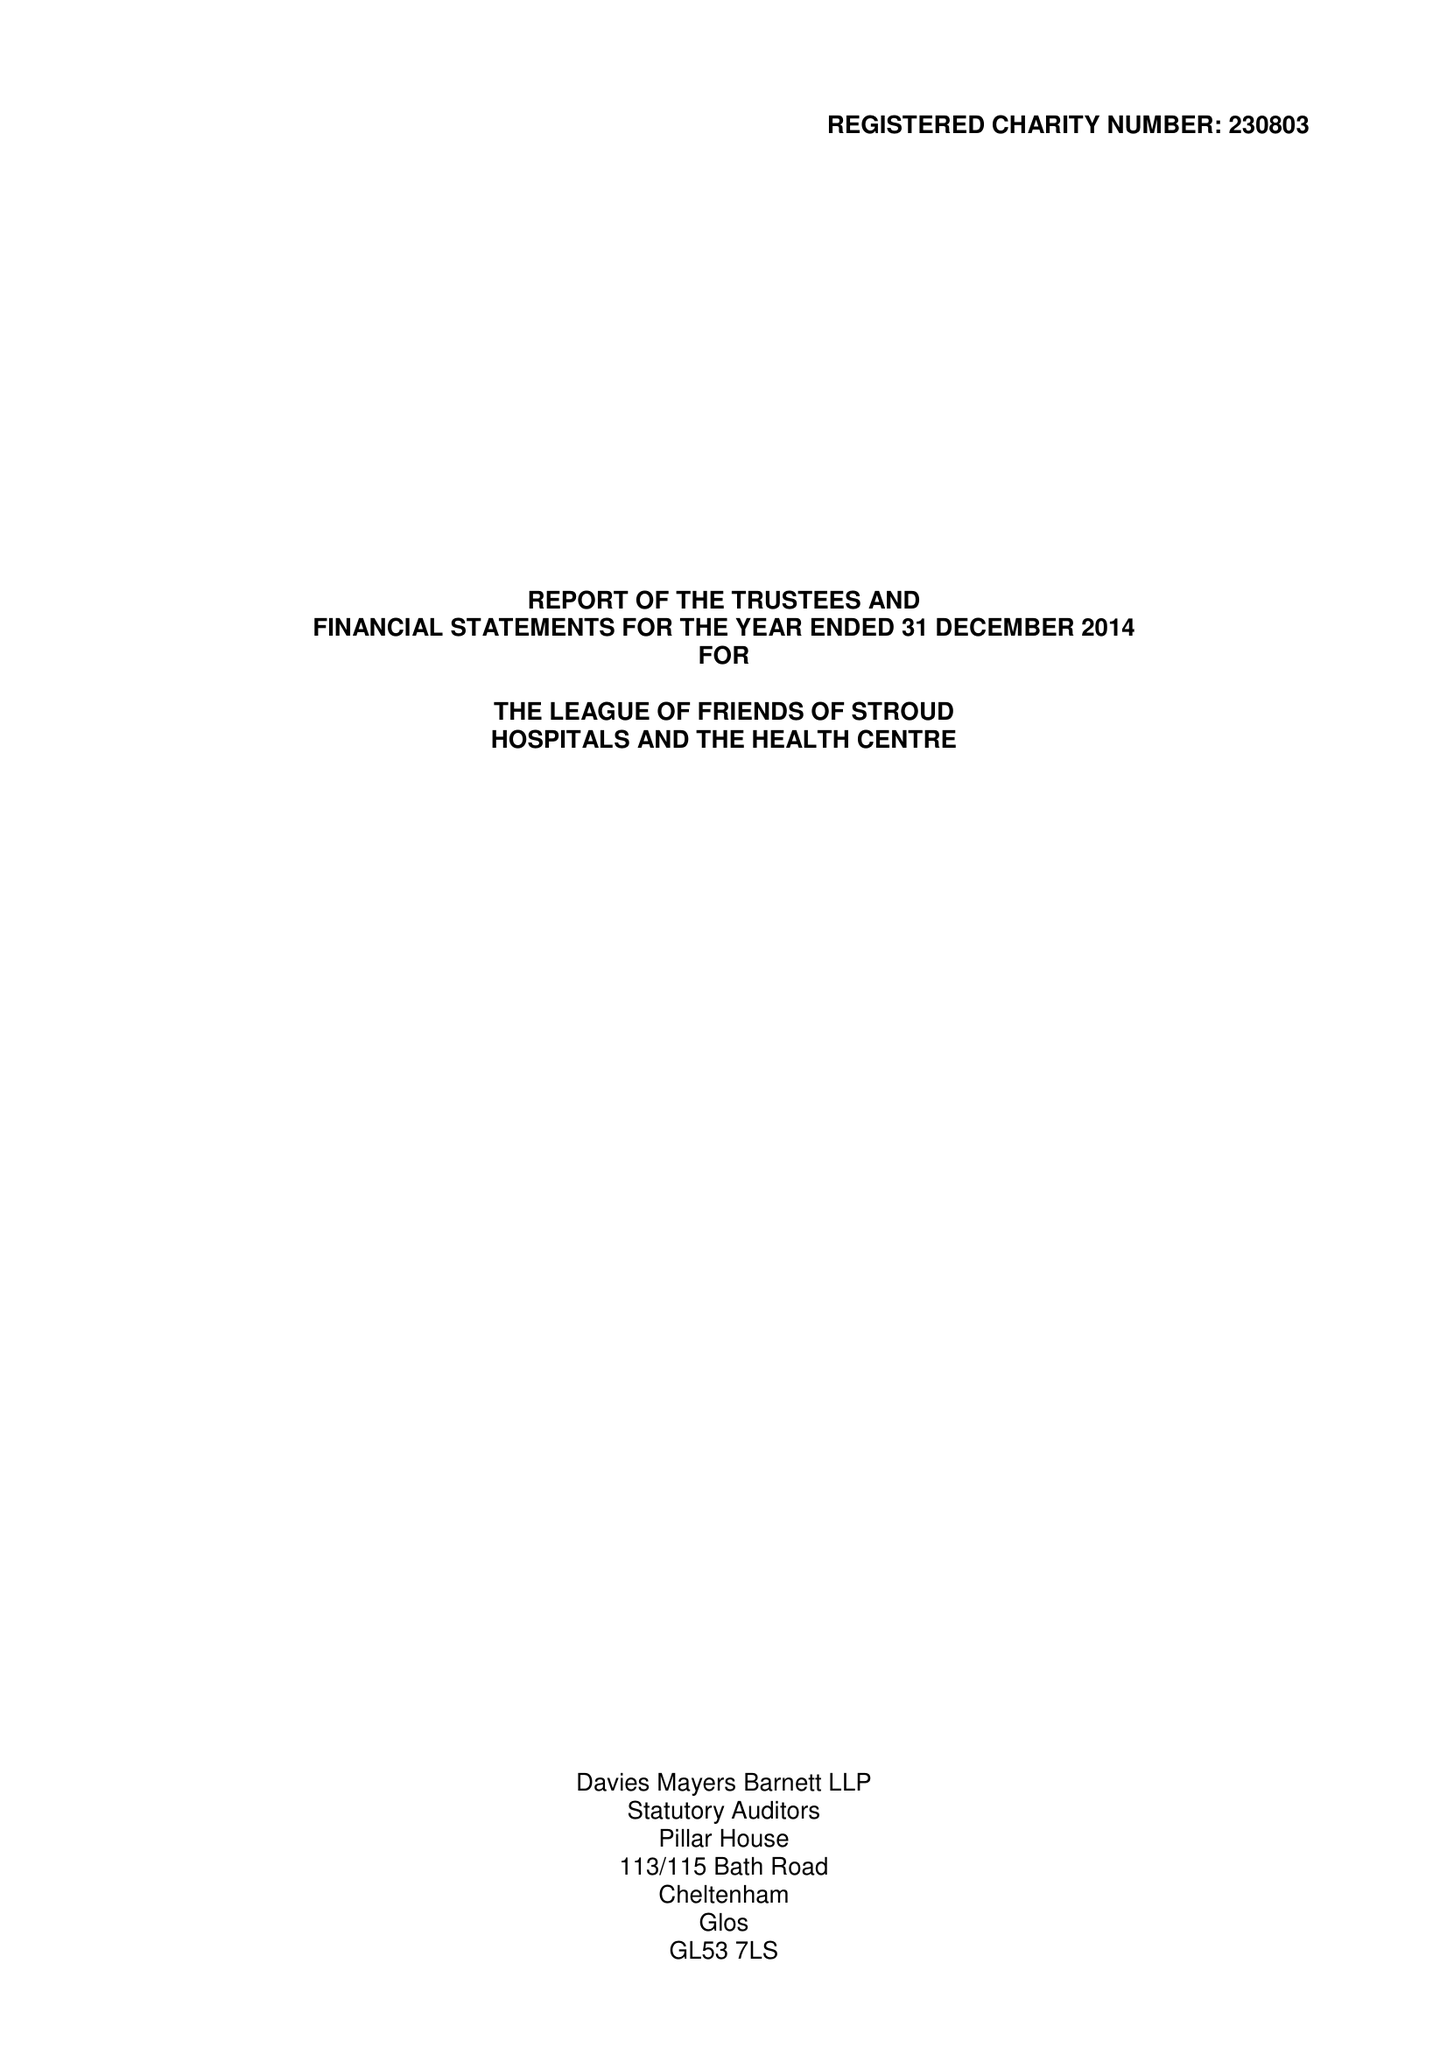What is the value for the address__street_line?
Answer the question using a single word or phrase. None 